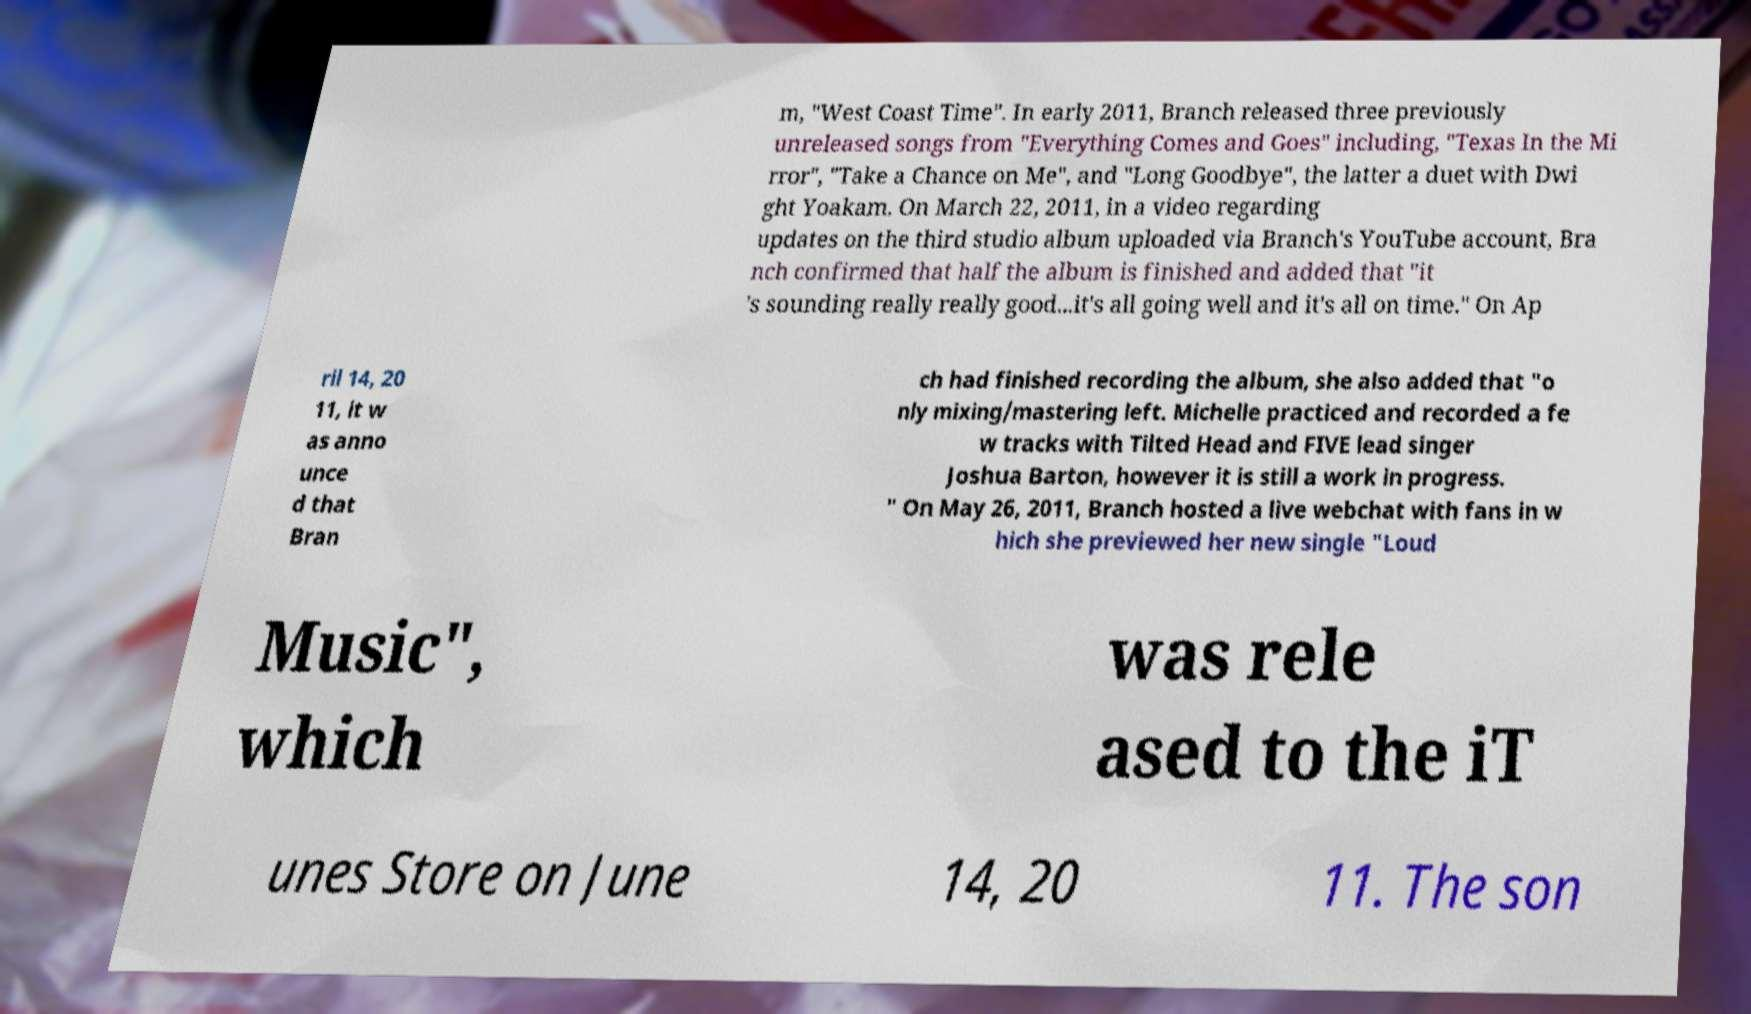What messages or text are displayed in this image? I need them in a readable, typed format. m, "West Coast Time". In early 2011, Branch released three previously unreleased songs from "Everything Comes and Goes" including, "Texas In the Mi rror", "Take a Chance on Me", and "Long Goodbye", the latter a duet with Dwi ght Yoakam. On March 22, 2011, in a video regarding updates on the third studio album uploaded via Branch's YouTube account, Bra nch confirmed that half the album is finished and added that "it 's sounding really really good...it's all going well and it's all on time." On Ap ril 14, 20 11, it w as anno unce d that Bran ch had finished recording the album, she also added that "o nly mixing/mastering left. Michelle practiced and recorded a fe w tracks with Tilted Head and FIVE lead singer Joshua Barton, however it is still a work in progress. " On May 26, 2011, Branch hosted a live webchat with fans in w hich she previewed her new single "Loud Music", which was rele ased to the iT unes Store on June 14, 20 11. The son 